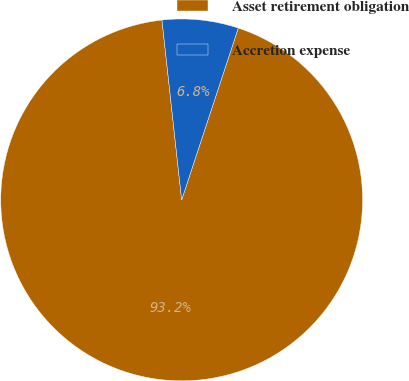<chart> <loc_0><loc_0><loc_500><loc_500><pie_chart><fcel>Asset retirement obligation<fcel>Accretion expense<nl><fcel>93.2%<fcel>6.8%<nl></chart> 